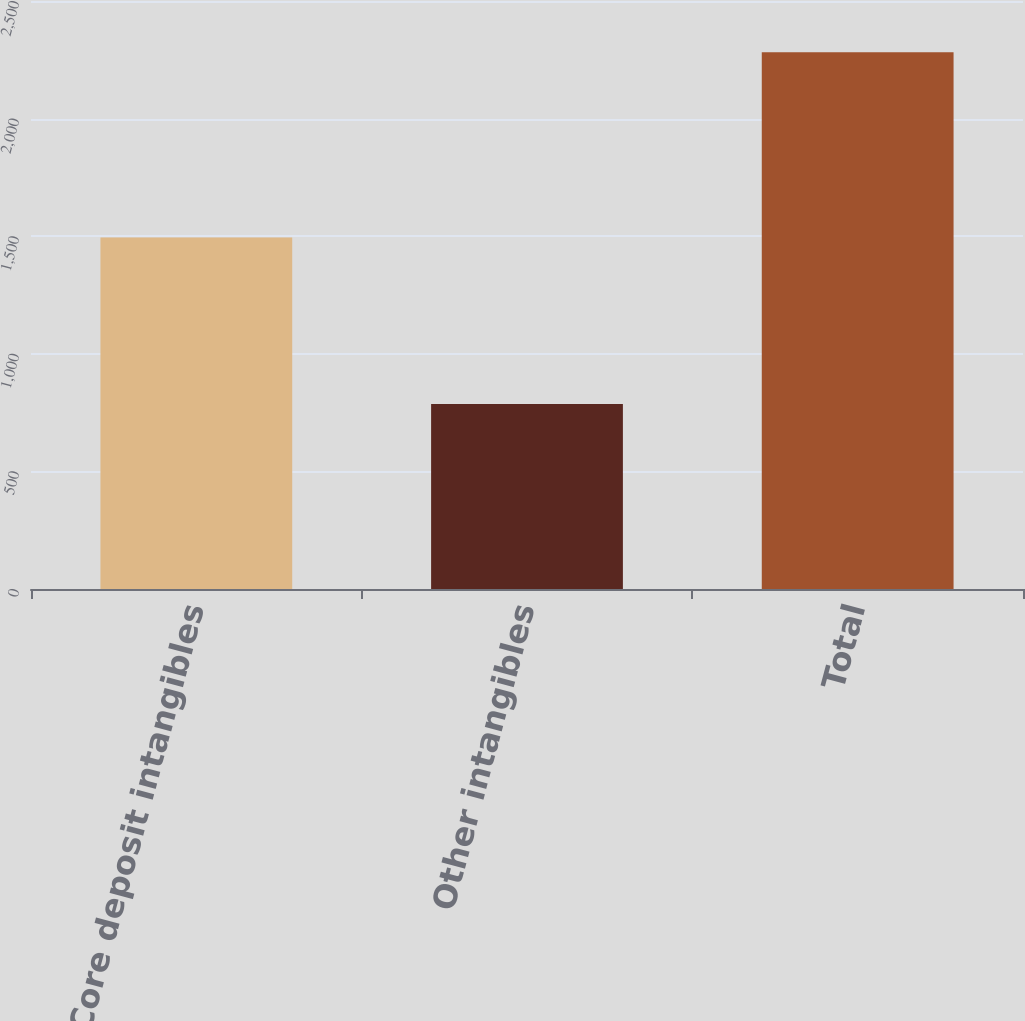Convert chart to OTSL. <chart><loc_0><loc_0><loc_500><loc_500><bar_chart><fcel>Core deposit intangibles<fcel>Other intangibles<fcel>Total<nl><fcel>1495<fcel>787<fcel>2282<nl></chart> 